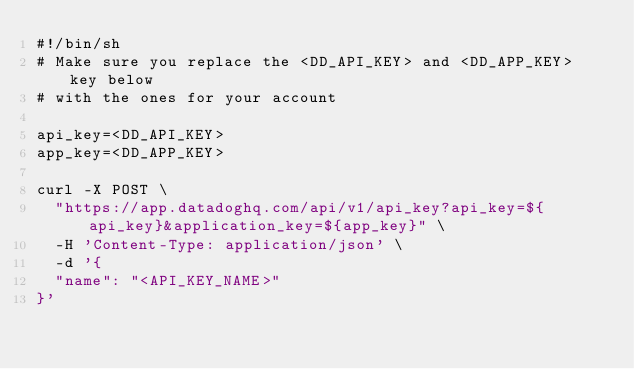<code> <loc_0><loc_0><loc_500><loc_500><_Bash_>#!/bin/sh
# Make sure you replace the <DD_API_KEY> and <DD_APP_KEY> key below
# with the ones for your account

api_key=<DD_API_KEY>
app_key=<DD_APP_KEY>

curl -X POST \
  "https://app.datadoghq.com/api/v1/api_key?api_key=${api_key}&application_key=${app_key}" \
  -H 'Content-Type: application/json' \
  -d '{
	"name": "<API_KEY_NAME>"
}'
</code> 